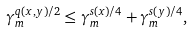Convert formula to latex. <formula><loc_0><loc_0><loc_500><loc_500>\gamma _ { m } ^ { q ( x , y ) / 2 } \leq \gamma _ { m } ^ { s ( x ) / 4 } + \gamma _ { m } ^ { s ( y ) / 4 } ,</formula> 